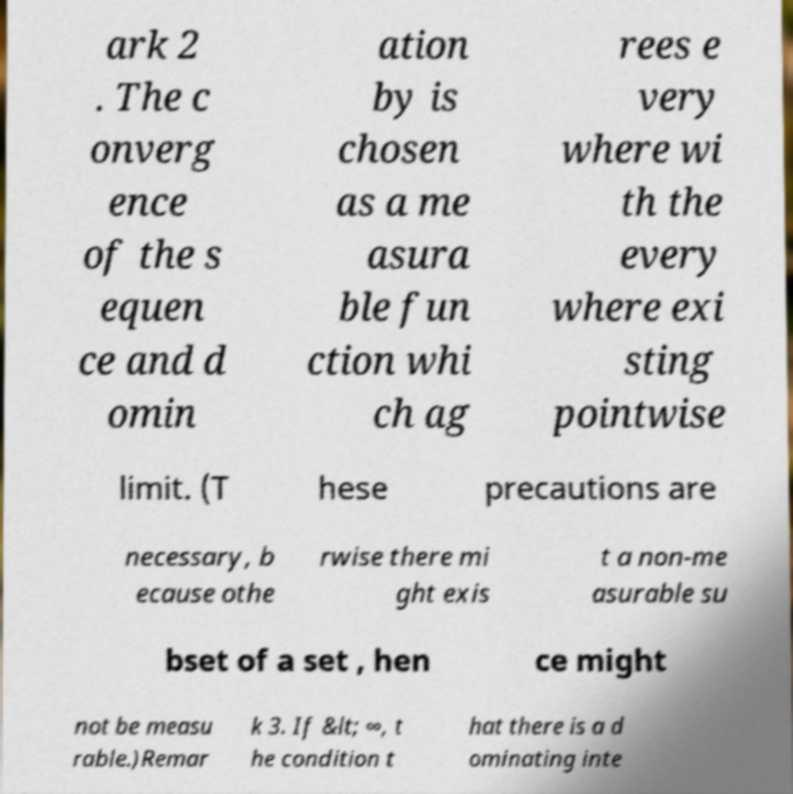Please identify and transcribe the text found in this image. ark 2 . The c onverg ence of the s equen ce and d omin ation by is chosen as a me asura ble fun ction whi ch ag rees e very where wi th the every where exi sting pointwise limit. (T hese precautions are necessary, b ecause othe rwise there mi ght exis t a non-me asurable su bset of a set , hen ce might not be measu rable.)Remar k 3. If &lt; ∞, t he condition t hat there is a d ominating inte 